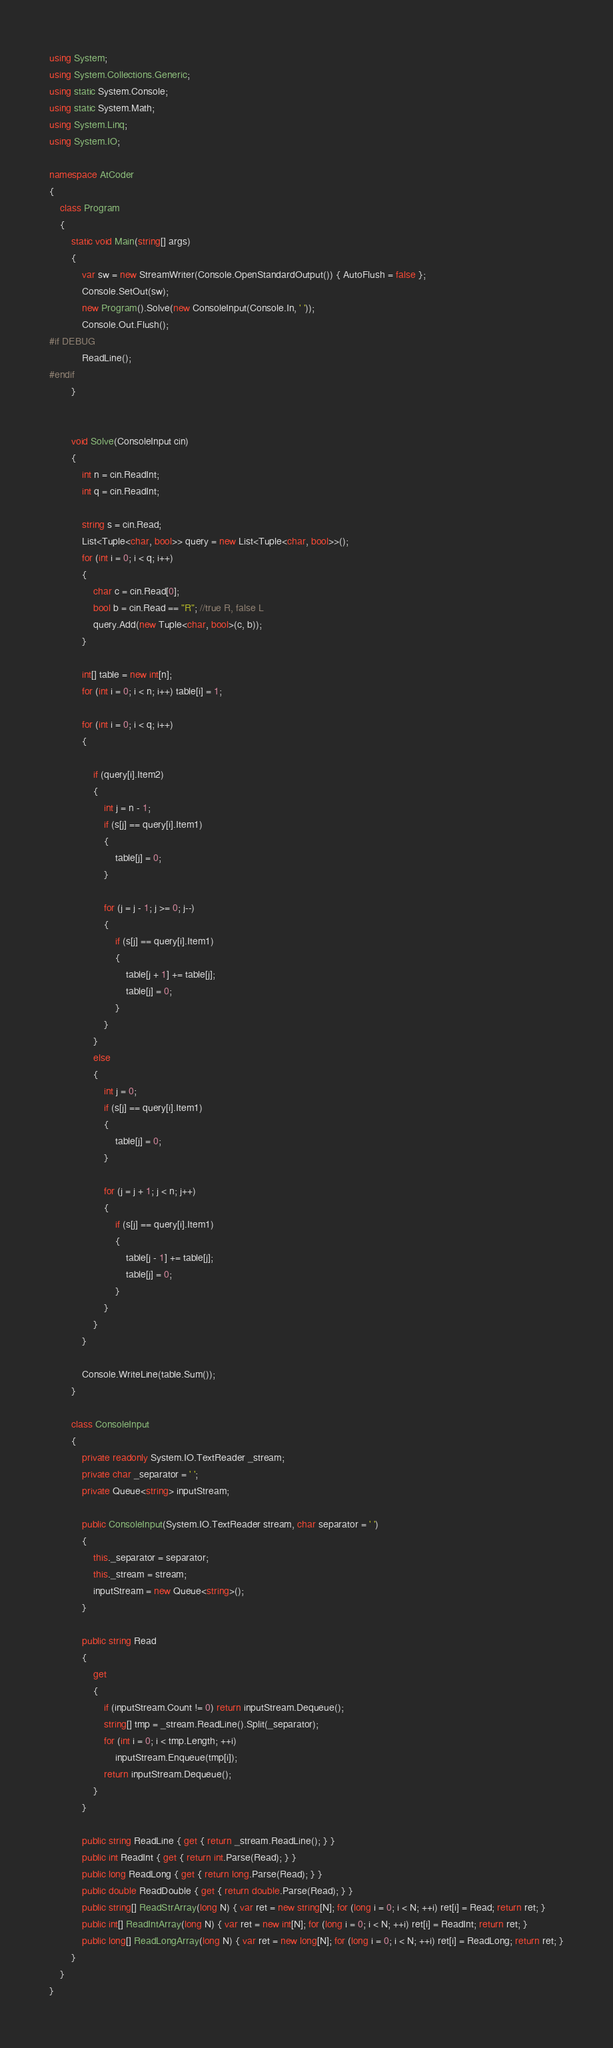<code> <loc_0><loc_0><loc_500><loc_500><_C#_>using System;
using System.Collections.Generic;
using static System.Console;
using static System.Math;
using System.Linq;
using System.IO;

namespace AtCoder
{
    class Program
    {
        static void Main(string[] args)
        {
            var sw = new StreamWriter(Console.OpenStandardOutput()) { AutoFlush = false };
            Console.SetOut(sw);
            new Program().Solve(new ConsoleInput(Console.In, ' '));
            Console.Out.Flush();
#if DEBUG
            ReadLine();
#endif
        }


        void Solve(ConsoleInput cin)
        {
            int n = cin.ReadInt;
            int q = cin.ReadInt;

            string s = cin.Read;
            List<Tuple<char, bool>> query = new List<Tuple<char, bool>>();
            for (int i = 0; i < q; i++)
            {
                char c = cin.Read[0];
                bool b = cin.Read == "R"; //true R, false L
                query.Add(new Tuple<char, bool>(c, b));
            }

            int[] table = new int[n];
            for (int i = 0; i < n; i++) table[i] = 1;

            for (int i = 0; i < q; i++)
            {

                if (query[i].Item2)
                {
                    int j = n - 1;
                    if (s[j] == query[i].Item1)
                    {
                        table[j] = 0;
                    }

                    for (j = j - 1; j >= 0; j--)
                    {
                        if (s[j] == query[i].Item1)
                        {
                            table[j + 1] += table[j];
                            table[j] = 0;
                        }
                    }
                }
                else
                {
                    int j = 0;
                    if (s[j] == query[i].Item1)
                    {
                        table[j] = 0;
                    }

                    for (j = j + 1; j < n; j++)
                    {
                        if (s[j] == query[i].Item1)
                        {
                            table[j - 1] += table[j];
                            table[j] = 0;
                        }
                    }
                }
            }

            Console.WriteLine(table.Sum());
        }

        class ConsoleInput
        {
            private readonly System.IO.TextReader _stream;
            private char _separator = ' ';
            private Queue<string> inputStream;

            public ConsoleInput(System.IO.TextReader stream, char separator = ' ')
            {
                this._separator = separator;
                this._stream = stream;
                inputStream = new Queue<string>();
            }

            public string Read
            {
                get
                {
                    if (inputStream.Count != 0) return inputStream.Dequeue();
                    string[] tmp = _stream.ReadLine().Split(_separator);
                    for (int i = 0; i < tmp.Length; ++i)
                        inputStream.Enqueue(tmp[i]);
                    return inputStream.Dequeue();
                }
            }

            public string ReadLine { get { return _stream.ReadLine(); } }
            public int ReadInt { get { return int.Parse(Read); } }
            public long ReadLong { get { return long.Parse(Read); } }
            public double ReadDouble { get { return double.Parse(Read); } }
            public string[] ReadStrArray(long N) { var ret = new string[N]; for (long i = 0; i < N; ++i) ret[i] = Read; return ret; }
            public int[] ReadIntArray(long N) { var ret = new int[N]; for (long i = 0; i < N; ++i) ret[i] = ReadInt; return ret; }
            public long[] ReadLongArray(long N) { var ret = new long[N]; for (long i = 0; i < N; ++i) ret[i] = ReadLong; return ret; }
        }
    }
}</code> 